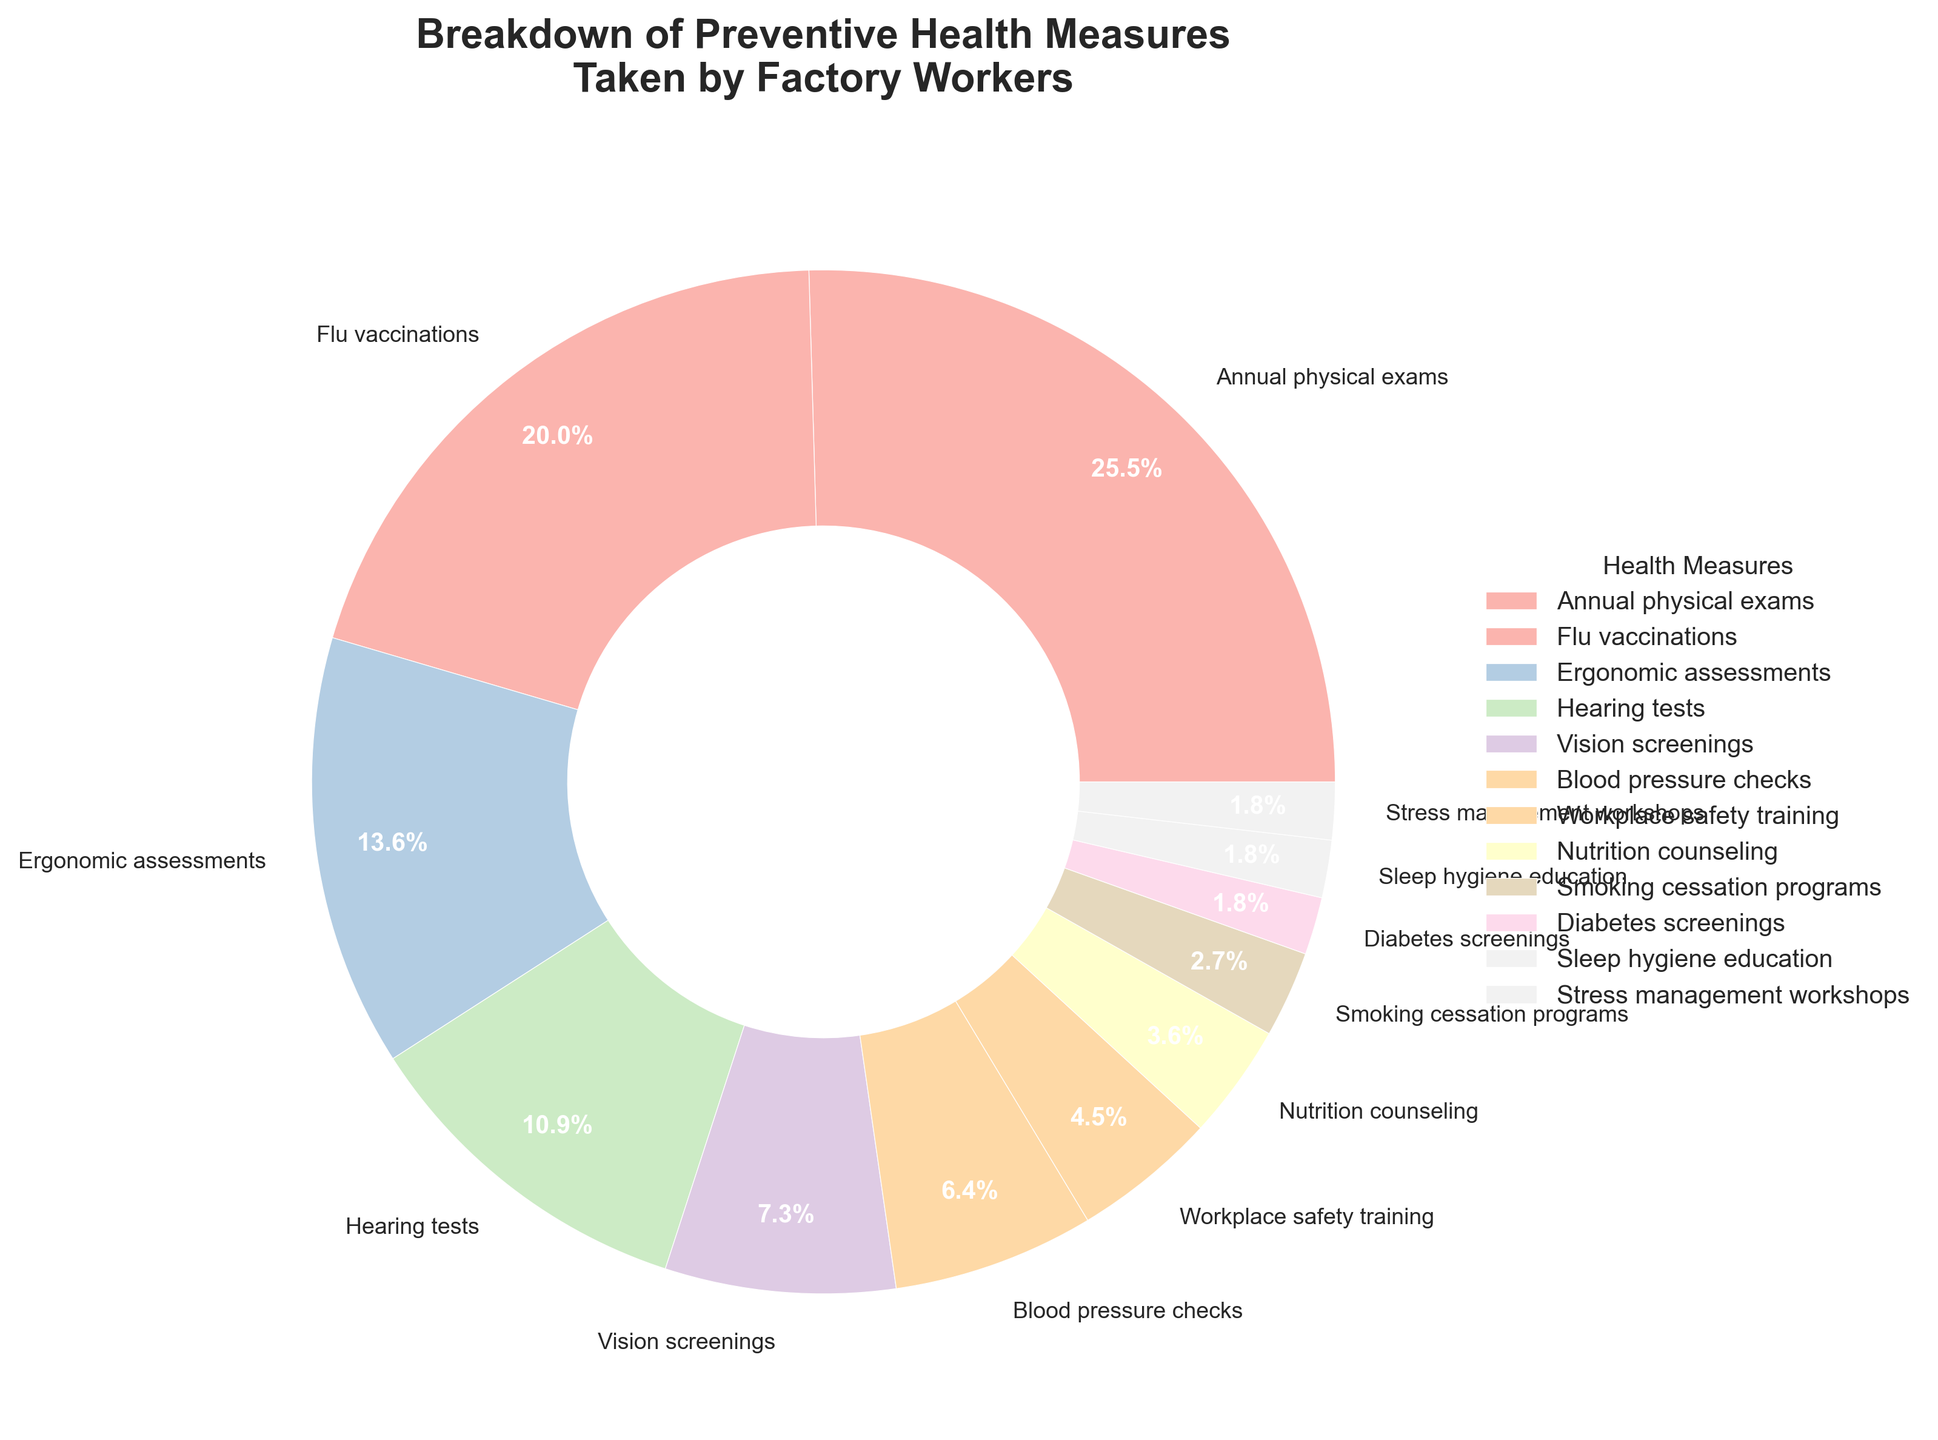What's the most common preventive health measure taken by factory workers? The most common measure is the one with the highest percentage in the pie chart. Here, "Annual physical exams" have the highest percentage at 28%.
Answer: Annual physical exams How many preventive health measures are taken by less than 10% of factory workers? Measures with less than 10% can be identified from the pie chart segments. These are: Vision screenings (8%), Blood pressure checks (7%), Nutrition counseling (4%), Smoking cessation programs (3%), Stress management workshops (2%), Workplace safety training (5%), Sleep hygiene education (2%), Diabetes screenings (2%). There are 8 such measures.
Answer: 8 What is the percentage difference between the most and least common preventive health measures? The most common measure is "Annual physical exams" at 28%, and the least common measures are "Stress management workshops," "Sleep hygiene education," and "Diabetes screenings," each at 2%. The difference is 28% - 2% = 26%.
Answer: 26% List the preventive health measures that form more than 20% of the total. From the pie chart, measures that form more than 20% are "Annual physical exams" (28%) and "Flu vaccinations" (22%).
Answer: Annual physical exams, Flu vaccinations Which preventive health measures have the closest percentages? Compare the percentages visually and identify the closest ones. "Stress management workshops" (2%), "Sleep hygiene education" (2%), and "Diabetes screenings" (2%) have the exact same percentage. Additionally, "Vision screenings" (8%) and "Blood pressure checks" (7%) are quite close.
Answer: Stress management workshops, Sleep hygiene education, Diabetes screenings; Vision screenings, Blood pressure checks What is the combined percentage of preventive health measures related to vision and hearing? Add the percentages of "Vision screenings" (8%) and "Hearing tests" (12%). The combined percentage is 8% + 12% = 20%.
Answer: 20% Do ergonomic assessments or flu vaccinations have a greater share among factory workers? Compare the segments for "Ergonomic assessments" (15%) and "Flu vaccinations" (22%). "Flu vaccinations" have a greater share.
Answer: Flu vaccinations Which has a higher percentage: workplace safety training or nutrition counseling? Compare "Workplace safety training" (5%) and "Nutrition counseling" (4%). "Workplace safety training" has a higher percentage.
Answer: Workplace safety training What are the colors used for the top three preventive health measures? Observe the colors of the pie chart segments for the top three measures. "Annual physical exams" (28%), "Flu vaccinations" (22%), "Ergonomic assessments" (15%).
Answer: Pastel shades (dependent on the chart but could typically be soft blue, pink, and green in pastel shades) What is the percentage sum of the three least utilized health measures? Identify the least utilized measures and sum their percentages: "Stress management workshops" (2%), "Sleep hygiene education" (2%), and "Diabetes screenings" (2%). The sum is 2% + 2% + 2% = 6%.
Answer: 6% 